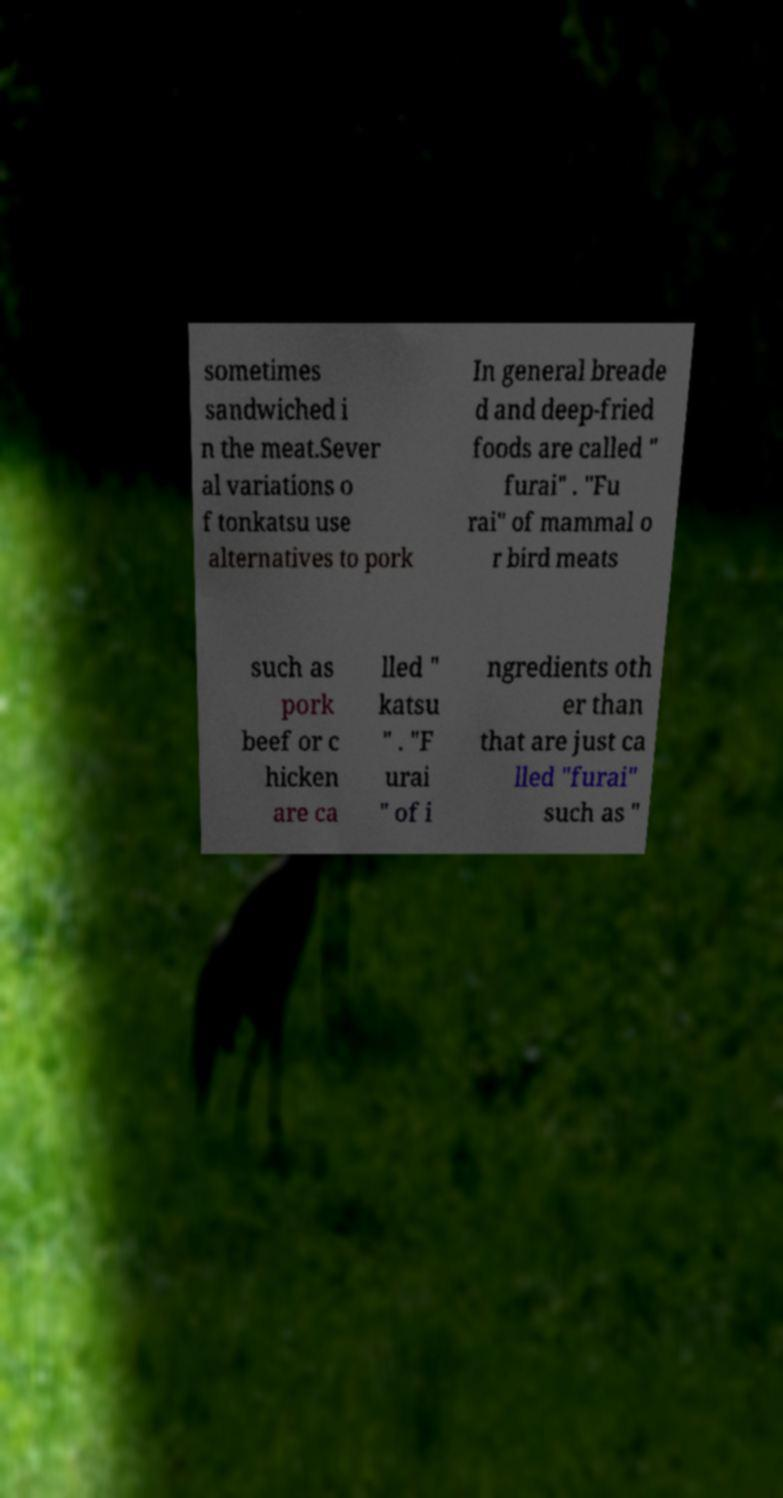For documentation purposes, I need the text within this image transcribed. Could you provide that? sometimes sandwiched i n the meat.Sever al variations o f tonkatsu use alternatives to pork In general breade d and deep-fried foods are called " furai" . "Fu rai" of mammal o r bird meats such as pork beef or c hicken are ca lled " katsu " . "F urai " of i ngredients oth er than that are just ca lled "furai" such as " 